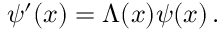Convert formula to latex. <formula><loc_0><loc_0><loc_500><loc_500>\psi ^ { \prime } ( x ) = \Lambda ( x ) \psi ( x ) \, .</formula> 